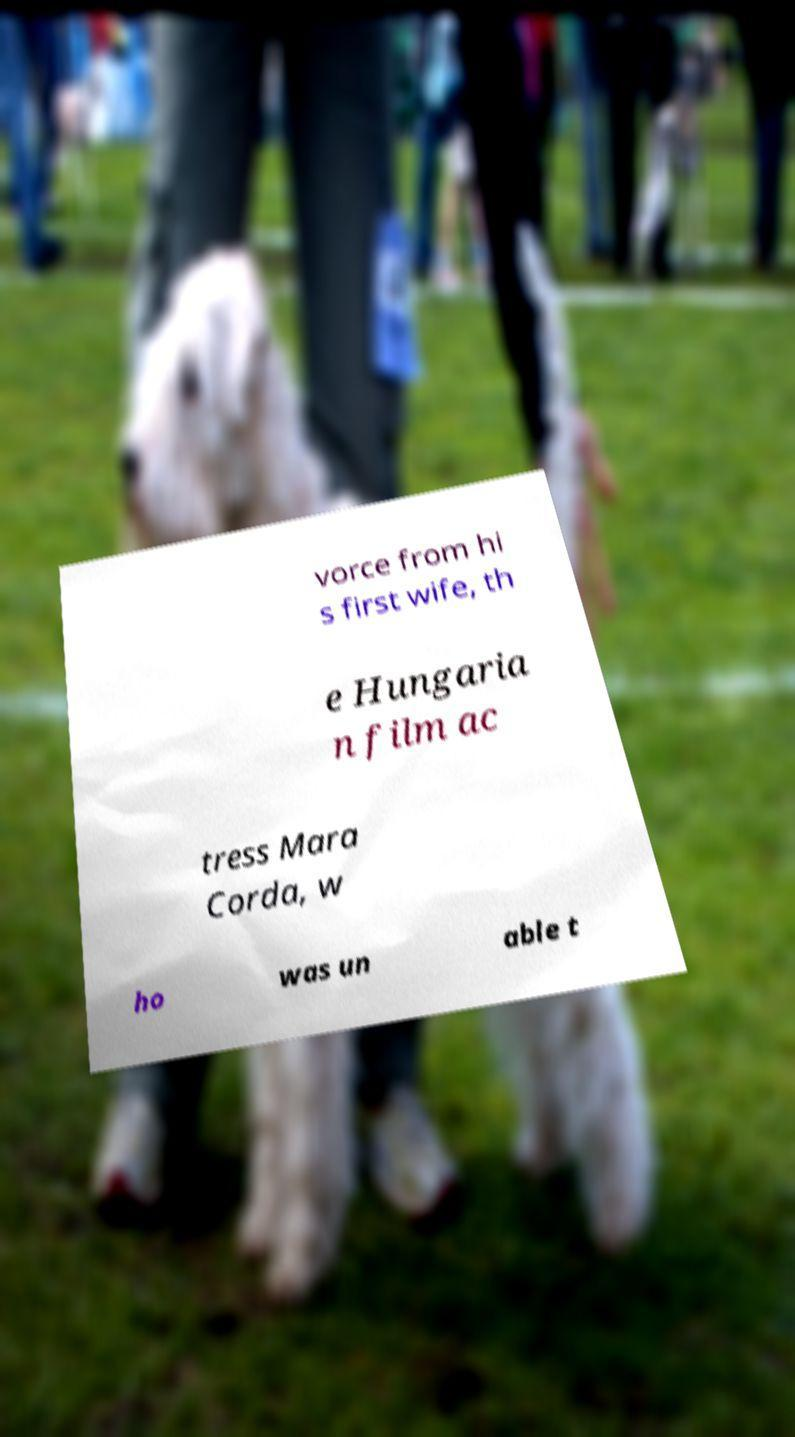Could you extract and type out the text from this image? vorce from hi s first wife, th e Hungaria n film ac tress Mara Corda, w ho was un able t 